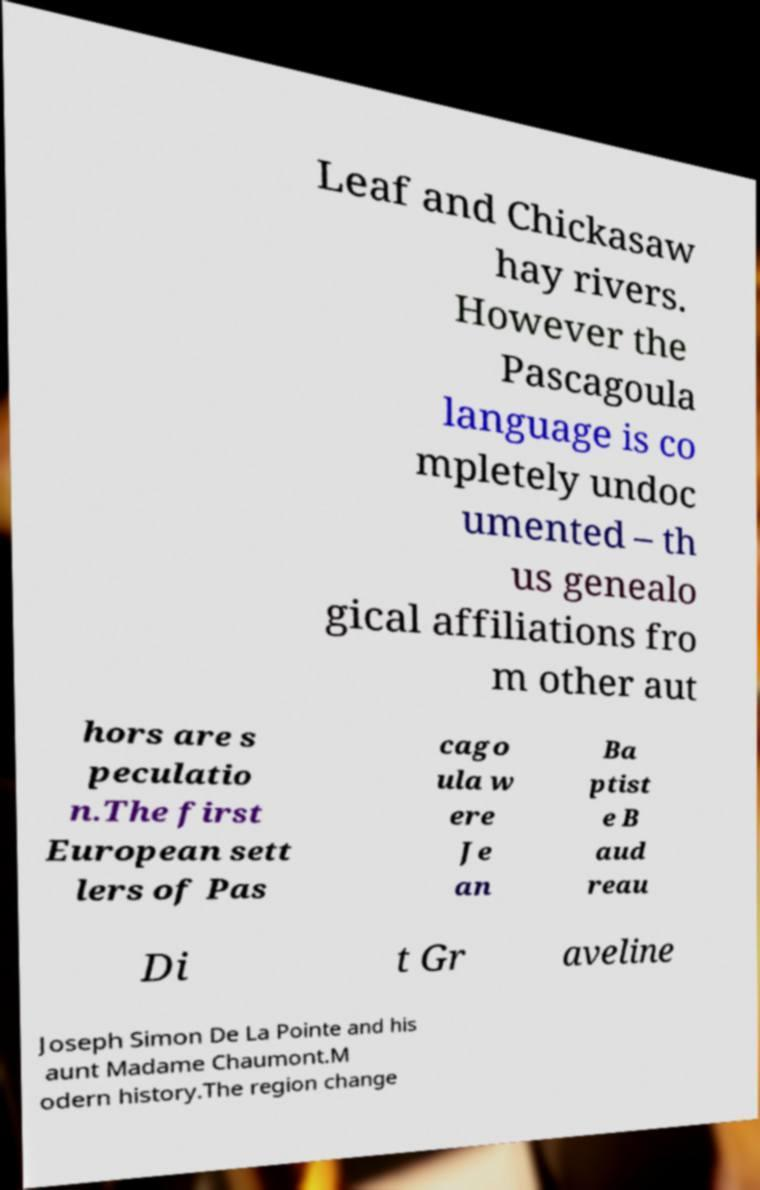I need the written content from this picture converted into text. Can you do that? Leaf and Chickasaw hay rivers. However the Pascagoula language is co mpletely undoc umented – th us genealo gical affiliations fro m other aut hors are s peculatio n.The first European sett lers of Pas cago ula w ere Je an Ba ptist e B aud reau Di t Gr aveline Joseph Simon De La Pointe and his aunt Madame Chaumont.M odern history.The region change 